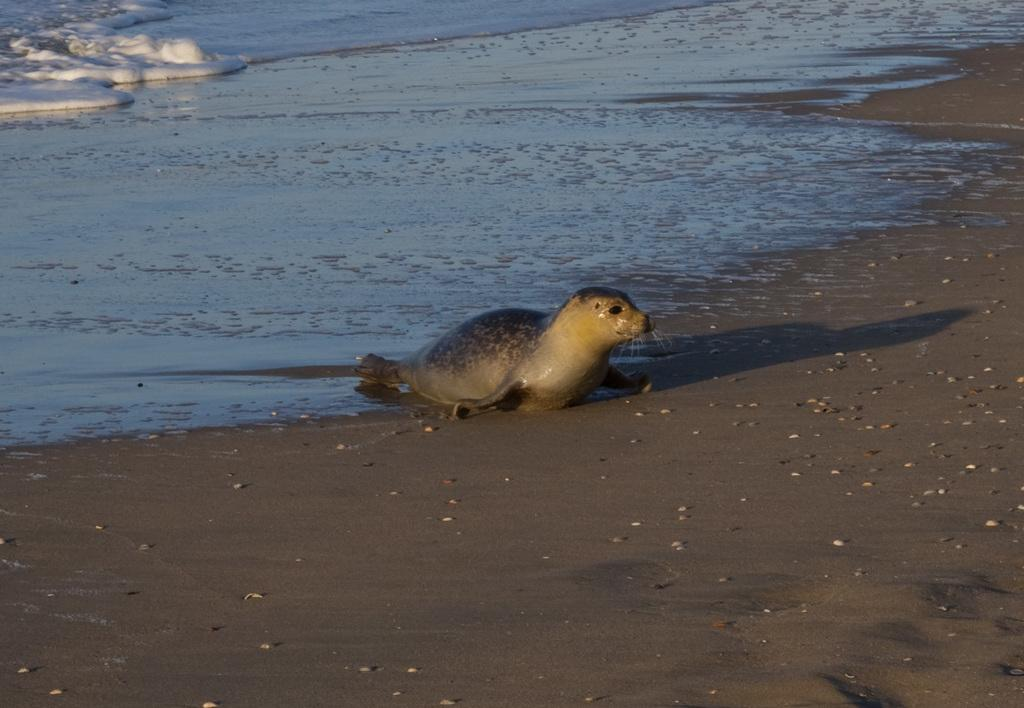What animal can be seen in the image? There is a seal in the image. Where is the seal located? The seal is on the ground in the image. What type of environment is depicted in the image? There is water and snow visible in the image. What type of net is being used to catch the toy in the image? There is no net or toy present in the image; it features a seal on the ground with water and snow visible. 